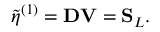<formula> <loc_0><loc_0><loc_500><loc_500>\tilde { \eta } ^ { ( 1 ) } = D V = S _ { L } .</formula> 